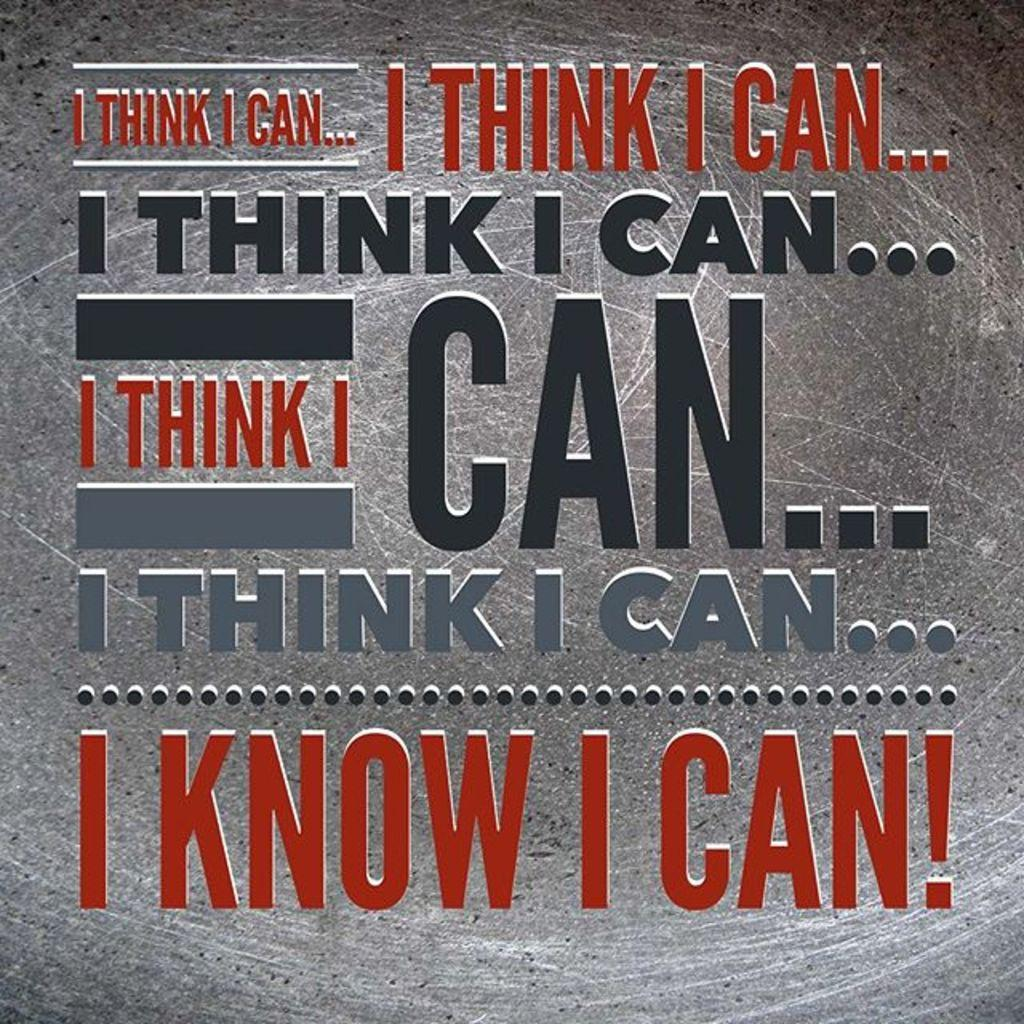<image>
Write a terse but informative summary of the picture. A motivation to people to think and know that you can do it. 